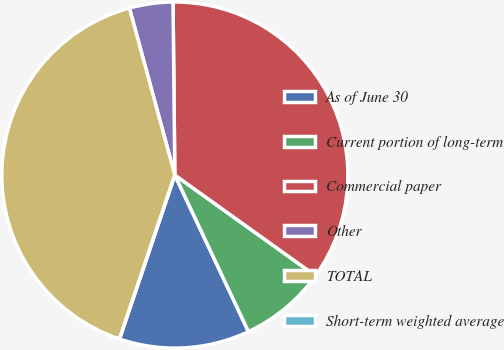Convert chart. <chart><loc_0><loc_0><loc_500><loc_500><pie_chart><fcel>As of June 30<fcel>Current portion of long-term<fcel>Commercial paper<fcel>Other<fcel>TOTAL<fcel>Short-term weighted average<nl><fcel>12.18%<fcel>8.12%<fcel>35.05%<fcel>4.06%<fcel>40.59%<fcel>0.0%<nl></chart> 